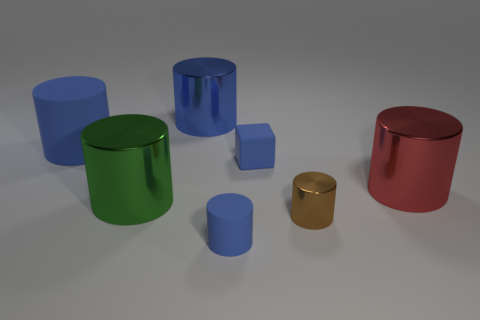Is the small brown cylinder made of the same material as the small cube?
Provide a short and direct response. No. How many green things are metal things or big rubber cylinders?
Ensure brevity in your answer.  1. What number of large green objects are the same shape as the brown shiny thing?
Offer a terse response. 1. What material is the brown object?
Provide a succinct answer. Metal. Are there the same number of blue metal things in front of the green metallic cylinder and brown things?
Give a very brief answer. No. What is the shape of the blue matte object that is the same size as the red object?
Provide a short and direct response. Cylinder. Are there any cylinders on the right side of the small rubber object behind the green metal object?
Give a very brief answer. Yes. What number of tiny objects are either brown metal things or blue blocks?
Ensure brevity in your answer.  2. Is there a brown cylinder that has the same size as the blue shiny object?
Make the answer very short. No. How many matte objects are small red things or big green cylinders?
Keep it short and to the point. 0. 